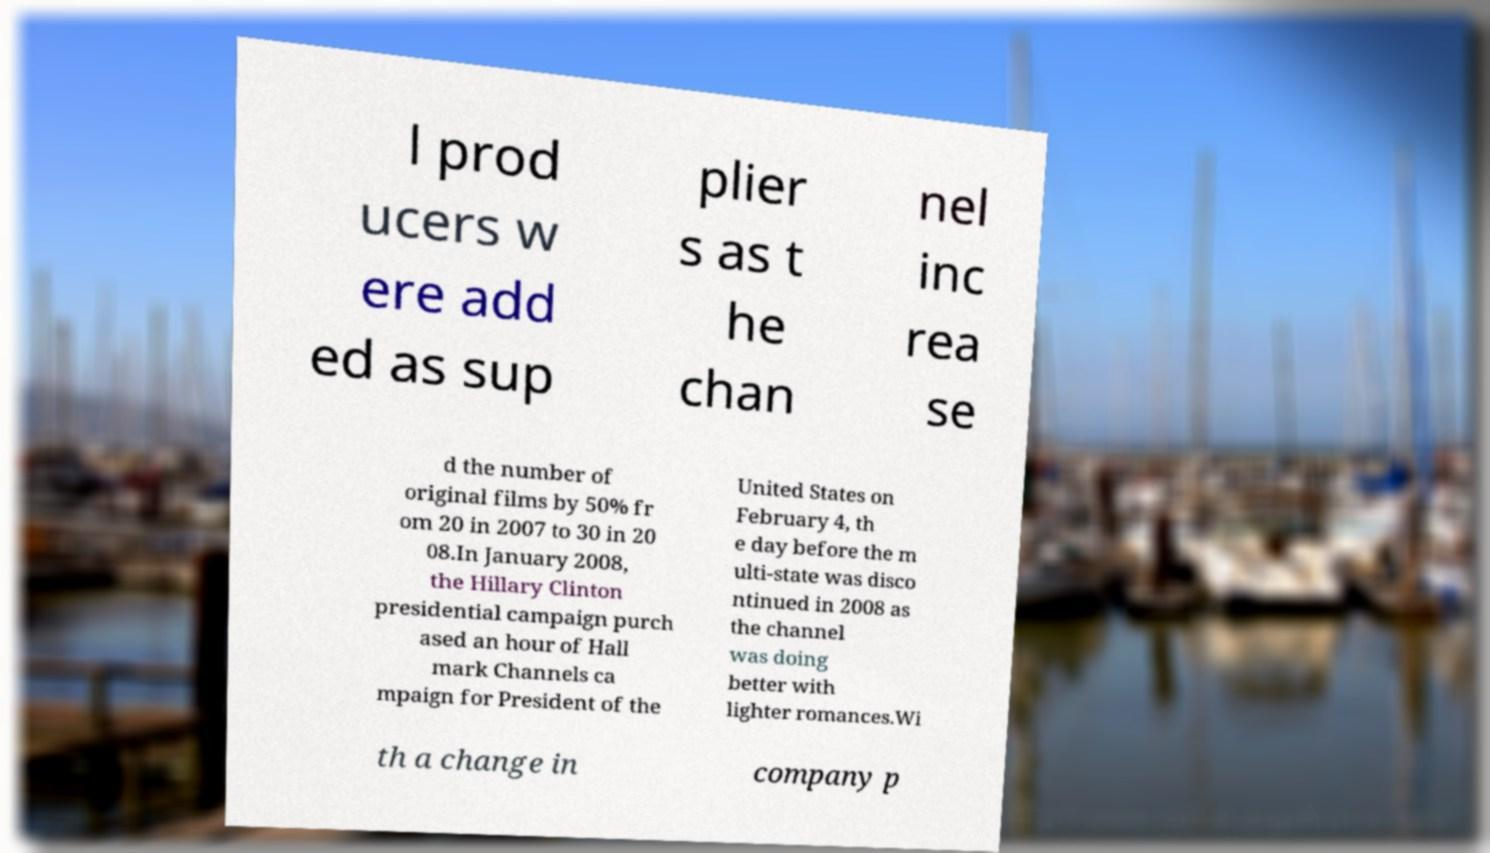Please identify and transcribe the text found in this image. l prod ucers w ere add ed as sup plier s as t he chan nel inc rea se d the number of original films by 50% fr om 20 in 2007 to 30 in 20 08.In January 2008, the Hillary Clinton presidential campaign purch ased an hour of Hall mark Channels ca mpaign for President of the United States on February 4, th e day before the m ulti-state was disco ntinued in 2008 as the channel was doing better with lighter romances.Wi th a change in company p 